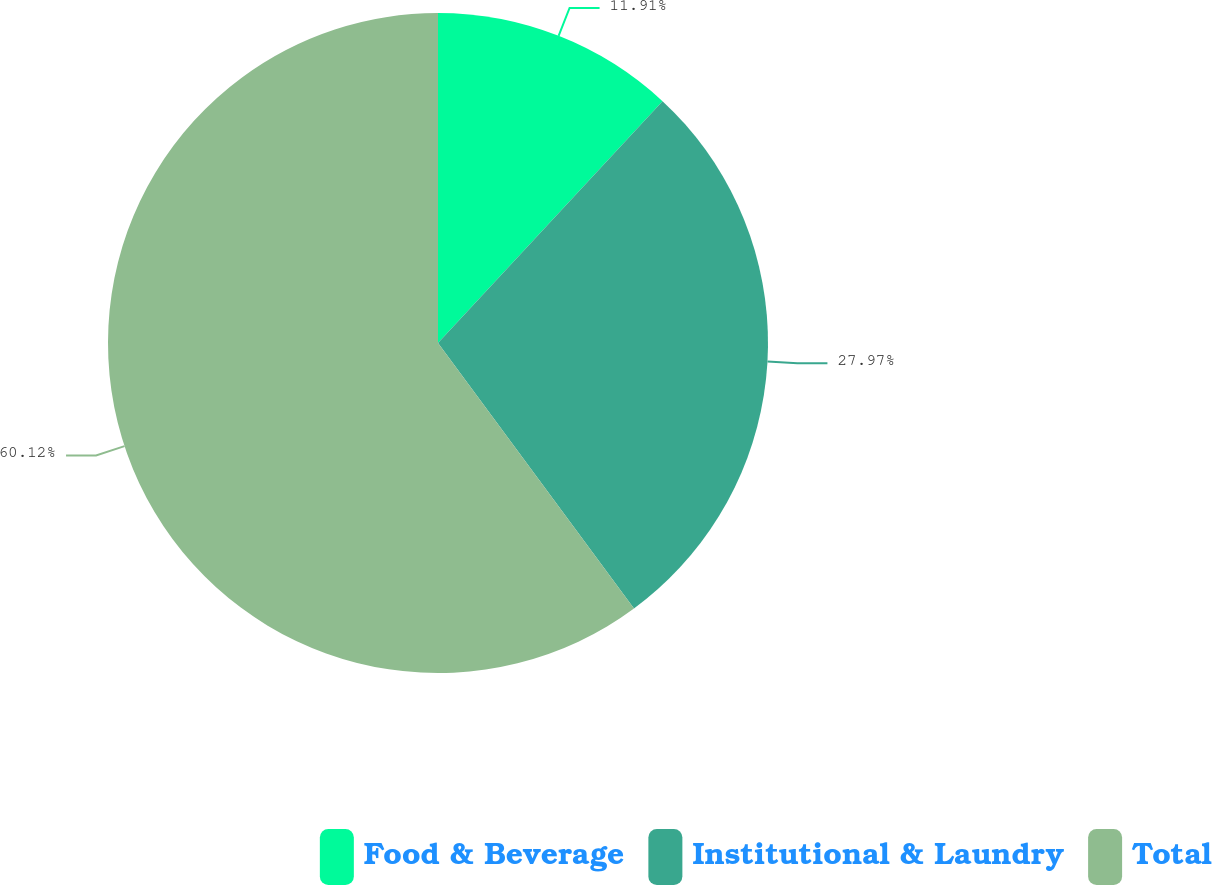Convert chart to OTSL. <chart><loc_0><loc_0><loc_500><loc_500><pie_chart><fcel>Food & Beverage<fcel>Institutional & Laundry<fcel>Total<nl><fcel>11.91%<fcel>27.97%<fcel>60.12%<nl></chart> 